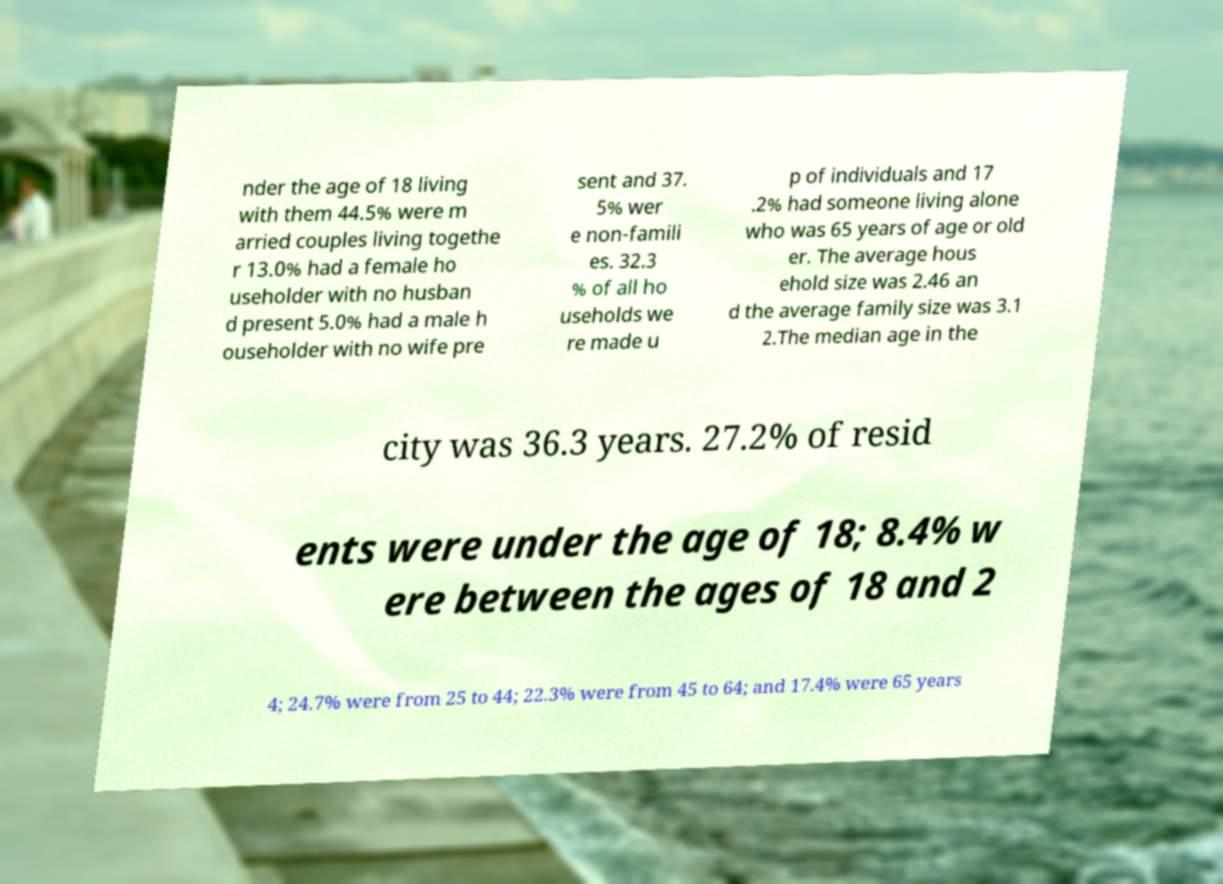I need the written content from this picture converted into text. Can you do that? nder the age of 18 living with them 44.5% were m arried couples living togethe r 13.0% had a female ho useholder with no husban d present 5.0% had a male h ouseholder with no wife pre sent and 37. 5% wer e non-famili es. 32.3 % of all ho useholds we re made u p of individuals and 17 .2% had someone living alone who was 65 years of age or old er. The average hous ehold size was 2.46 an d the average family size was 3.1 2.The median age in the city was 36.3 years. 27.2% of resid ents were under the age of 18; 8.4% w ere between the ages of 18 and 2 4; 24.7% were from 25 to 44; 22.3% were from 45 to 64; and 17.4% were 65 years 